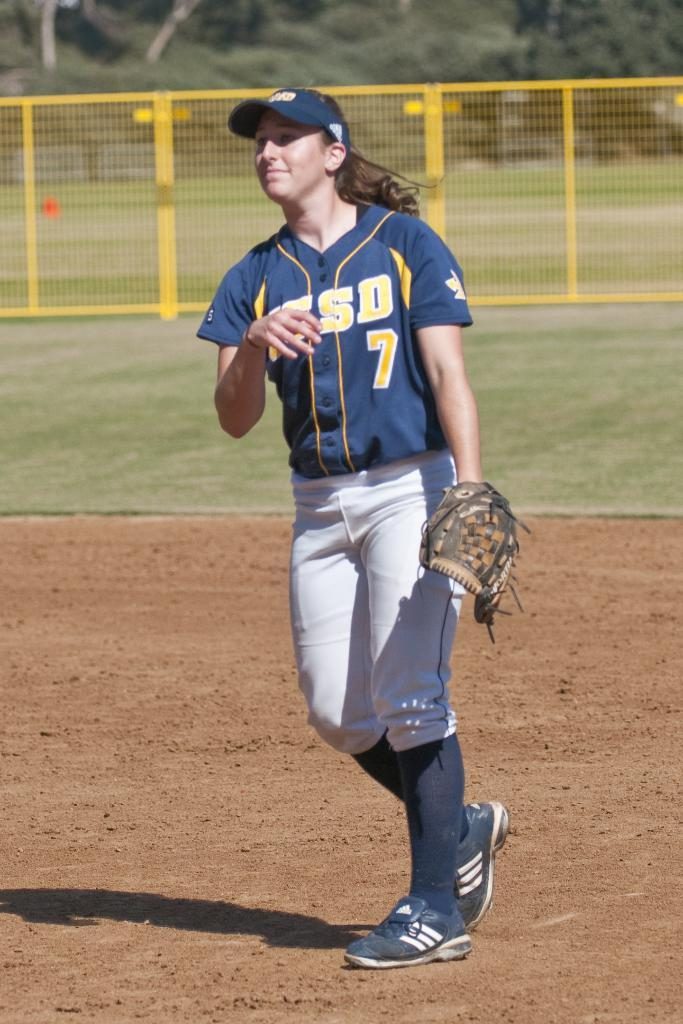<image>
Describe the image concisely. A female baseball player has the number seven on her jersey. 